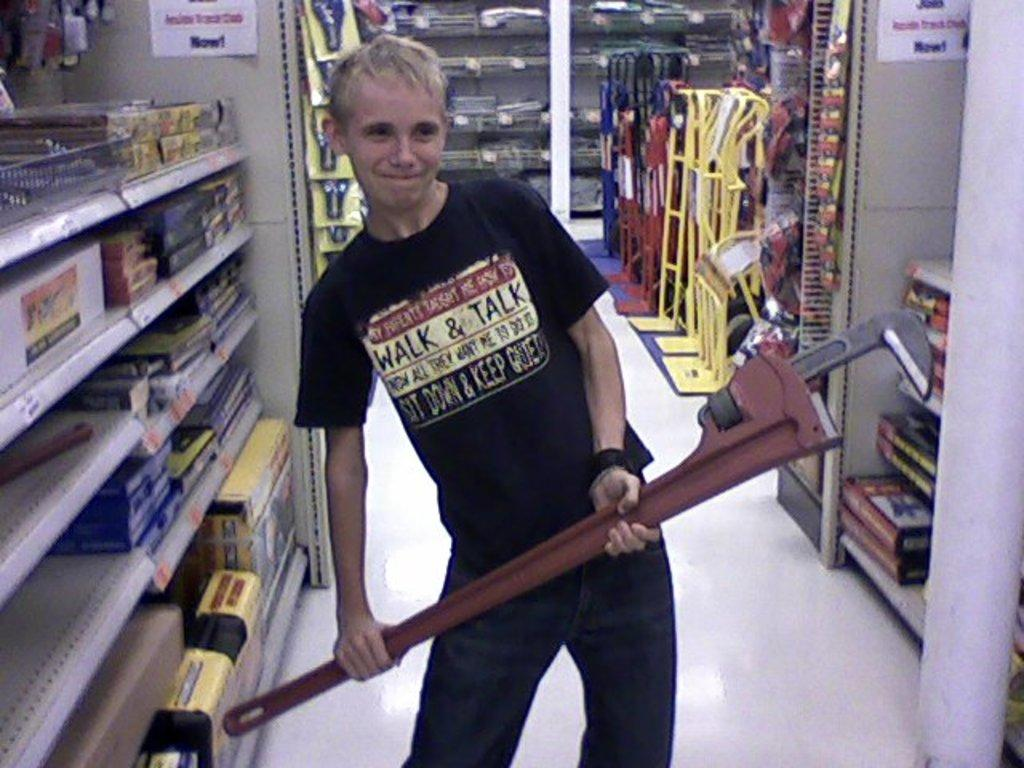What is the main subject of the image? There is a person standing in the image. What is the person holding in the image? The person is holding an object. What can be seen in the background of the image? There are racks in the image. What is stored on the racks? There are objects kept in the racks. What memory does the person recall while holding the object in the image? There is no indication in the image of the person recalling a memory or any specific thoughts while holding the object. 